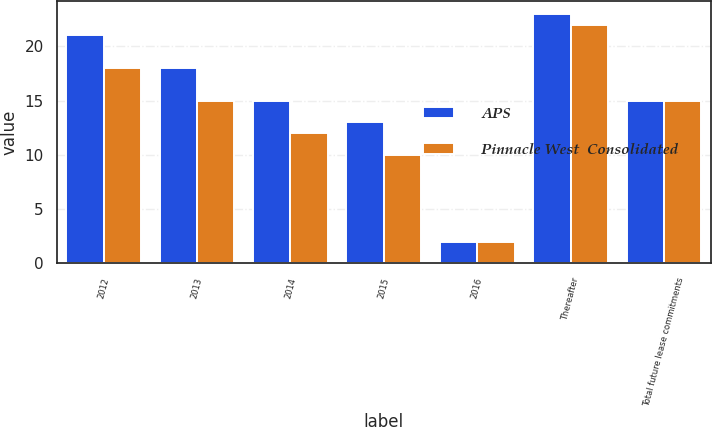Convert chart. <chart><loc_0><loc_0><loc_500><loc_500><stacked_bar_chart><ecel><fcel>2012<fcel>2013<fcel>2014<fcel>2015<fcel>2016<fcel>Thereafter<fcel>Total future lease commitments<nl><fcel>APS<fcel>21<fcel>18<fcel>15<fcel>13<fcel>2<fcel>23<fcel>15<nl><fcel>Pinnacle West  Consolidated<fcel>18<fcel>15<fcel>12<fcel>10<fcel>2<fcel>22<fcel>15<nl></chart> 